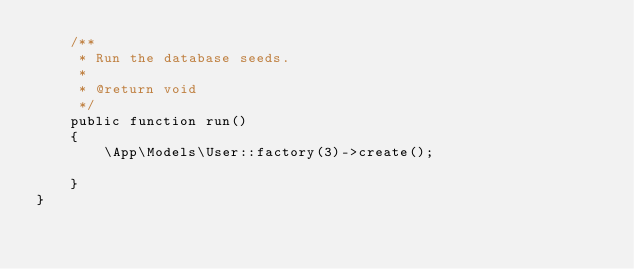<code> <loc_0><loc_0><loc_500><loc_500><_PHP_>    /**
     * Run the database seeds.
     *
     * @return void
     */
    public function run()
    {
        \App\Models\User::factory(3)->create();

    }
}
</code> 